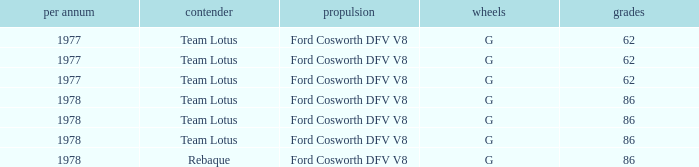What is the Motor that has a Focuses bigger than 62, and a Participant of rebaque? Ford Cosworth DFV V8. 